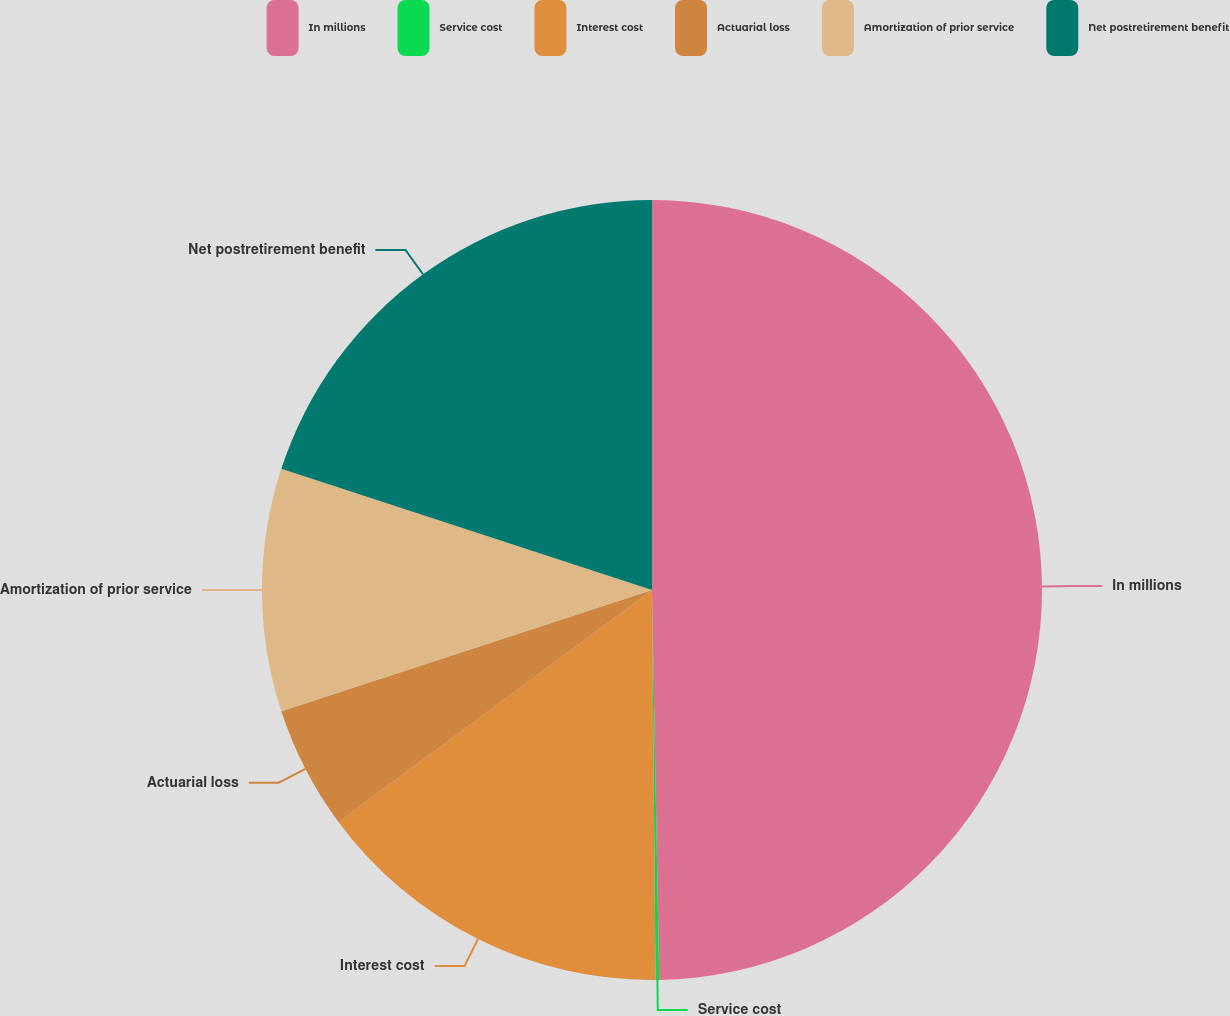<chart> <loc_0><loc_0><loc_500><loc_500><pie_chart><fcel>In millions<fcel>Service cost<fcel>Interest cost<fcel>Actuarial loss<fcel>Amortization of prior service<fcel>Net postretirement benefit<nl><fcel>49.7%<fcel>0.15%<fcel>15.01%<fcel>5.1%<fcel>10.06%<fcel>19.97%<nl></chart> 